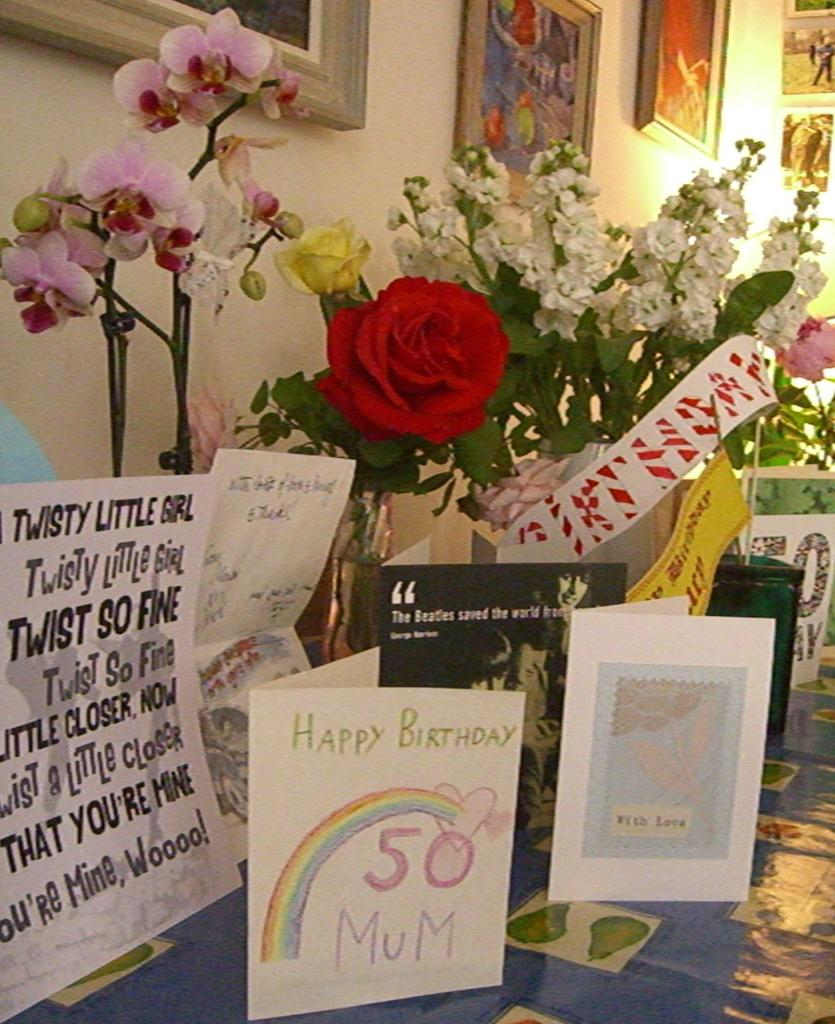What can be seen in the image that conveys a message or sentiment? There are greetings in the image. What type of decoration is present on the desk in the image? There are flowers on the desk in the image. What can be seen on the wall in the background of the image? There are frames on the wall in the background of the image. What type of lunch is being served in the image? There is no lunch present in the image. How many birds can be seen flying in the image? There are no birds visible in the image. 